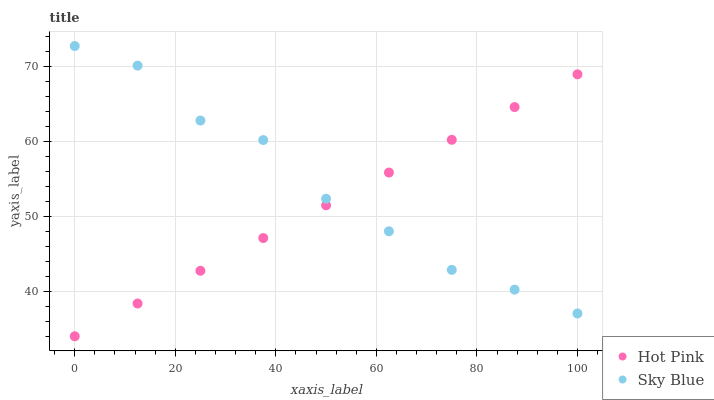Does Hot Pink have the minimum area under the curve?
Answer yes or no. Yes. Does Sky Blue have the maximum area under the curve?
Answer yes or no. Yes. Does Hot Pink have the maximum area under the curve?
Answer yes or no. No. Is Hot Pink the smoothest?
Answer yes or no. Yes. Is Sky Blue the roughest?
Answer yes or no. Yes. Is Hot Pink the roughest?
Answer yes or no. No. Does Hot Pink have the lowest value?
Answer yes or no. Yes. Does Sky Blue have the highest value?
Answer yes or no. Yes. Does Hot Pink have the highest value?
Answer yes or no. No. Does Sky Blue intersect Hot Pink?
Answer yes or no. Yes. Is Sky Blue less than Hot Pink?
Answer yes or no. No. Is Sky Blue greater than Hot Pink?
Answer yes or no. No. 